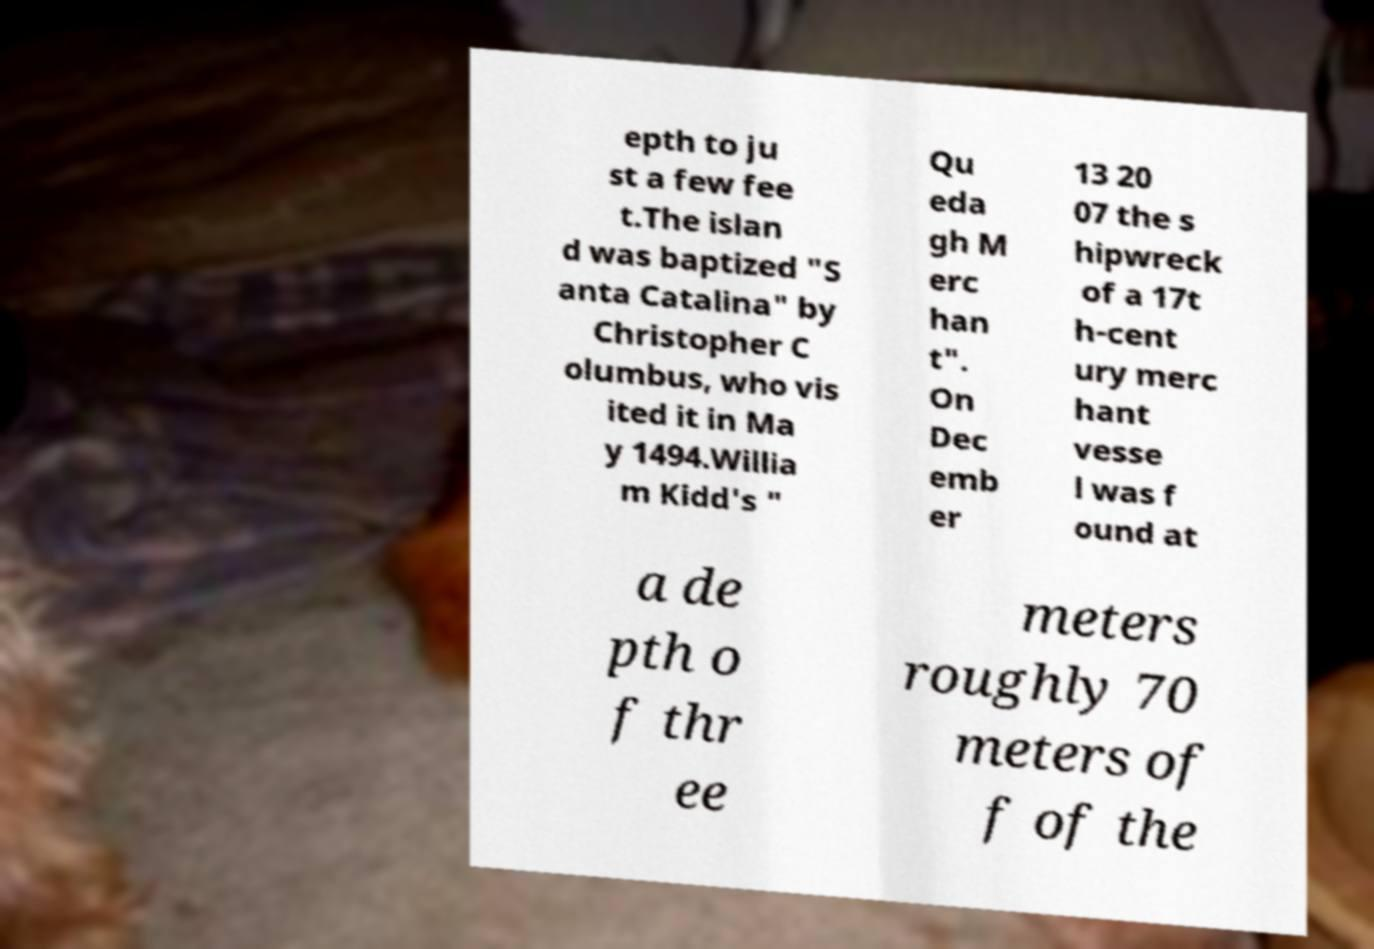What messages or text are displayed in this image? I need them in a readable, typed format. epth to ju st a few fee t.The islan d was baptized "S anta Catalina" by Christopher C olumbus, who vis ited it in Ma y 1494.Willia m Kidd's " Qu eda gh M erc han t". On Dec emb er 13 20 07 the s hipwreck of a 17t h-cent ury merc hant vesse l was f ound at a de pth o f thr ee meters roughly 70 meters of f of the 